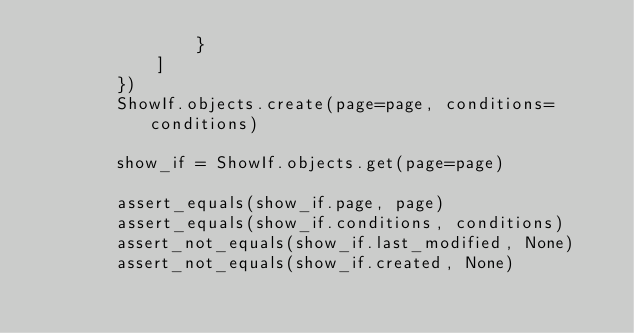<code> <loc_0><loc_0><loc_500><loc_500><_Python_>                }
            ]
        })
        ShowIf.objects.create(page=page, conditions=conditions)

        show_if = ShowIf.objects.get(page=page)

        assert_equals(show_if.page, page)
        assert_equals(show_if.conditions, conditions)
        assert_not_equals(show_if.last_modified, None)
        assert_not_equals(show_if.created, None)
</code> 